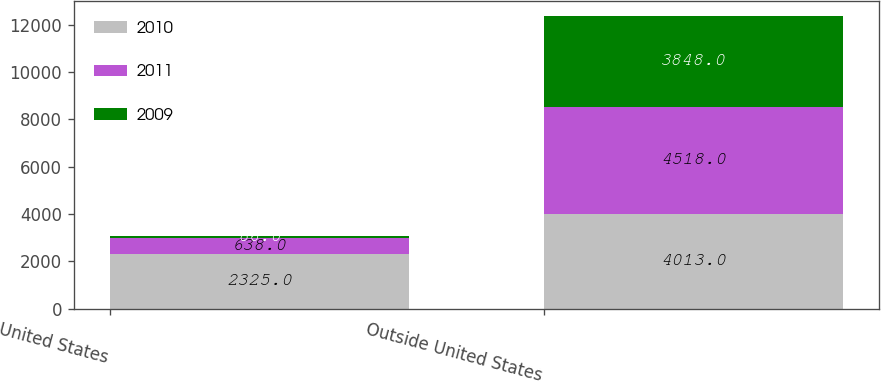<chart> <loc_0><loc_0><loc_500><loc_500><stacked_bar_chart><ecel><fcel>United States<fcel>Outside United States<nl><fcel>2010<fcel>2325<fcel>4013<nl><fcel>2011<fcel>638<fcel>4518<nl><fcel>2009<fcel>86<fcel>3848<nl></chart> 